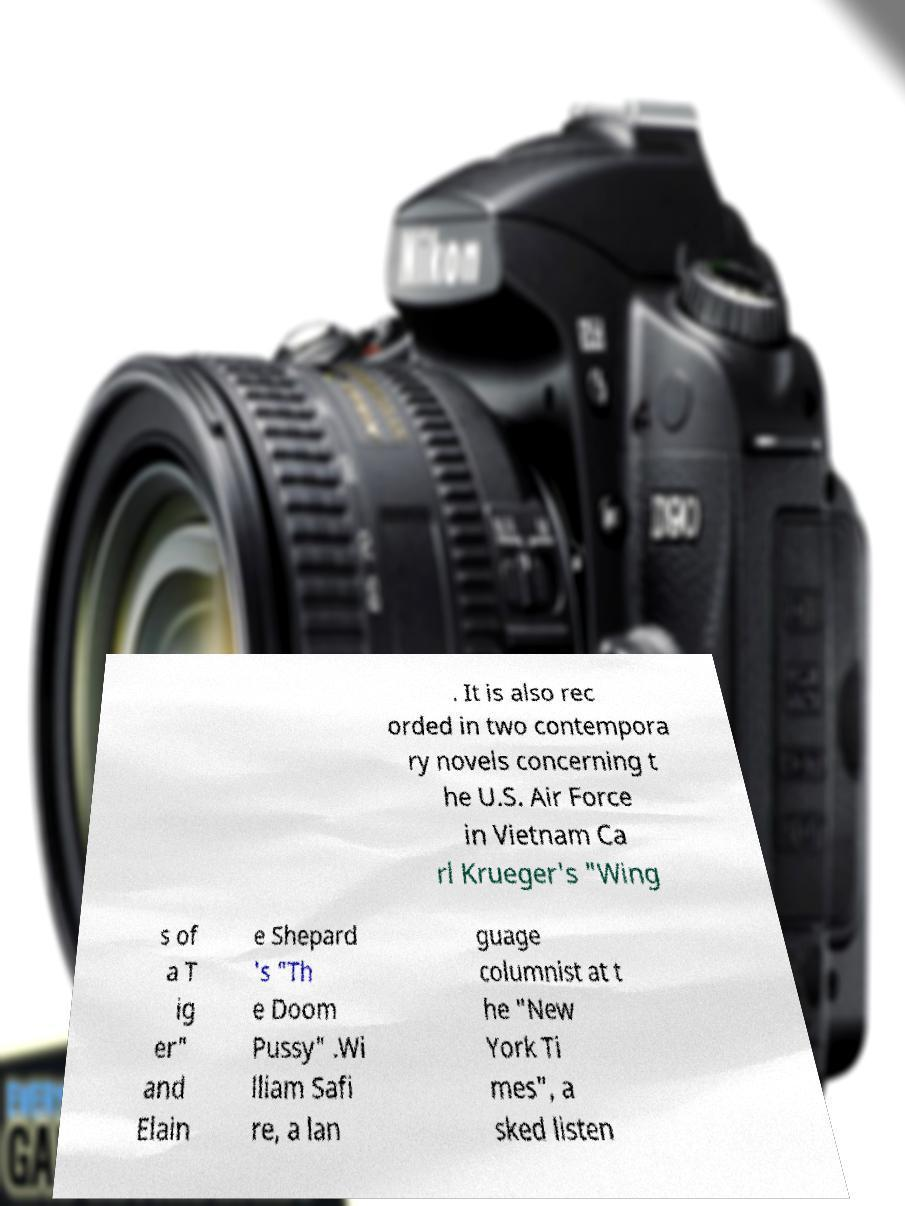What messages or text are displayed in this image? I need them in a readable, typed format. . It is also rec orded in two contempora ry novels concerning t he U.S. Air Force in Vietnam Ca rl Krueger's "Wing s of a T ig er" and Elain e Shepard 's "Th e Doom Pussy" .Wi lliam Safi re, a lan guage columnist at t he "New York Ti mes", a sked listen 